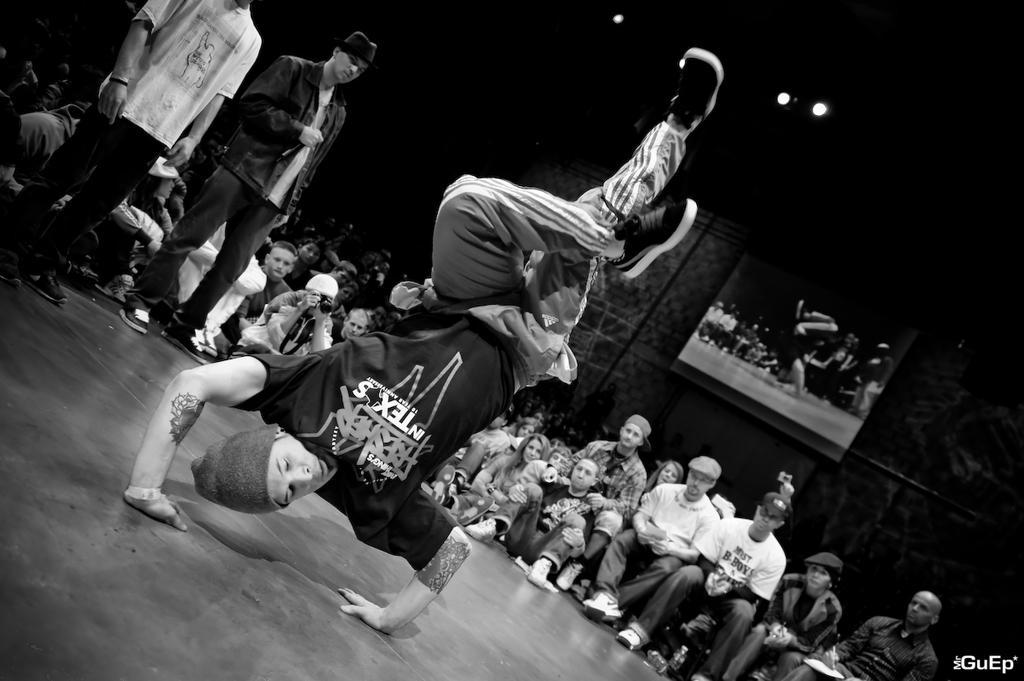Describe this image in one or two sentences. In this image we can see a person wearing black color T-shirt, white color pant, black color shoes doing gymnastics and in the background of the image there are some persons sitting and standing and there is a wall to which some posters are attached. 